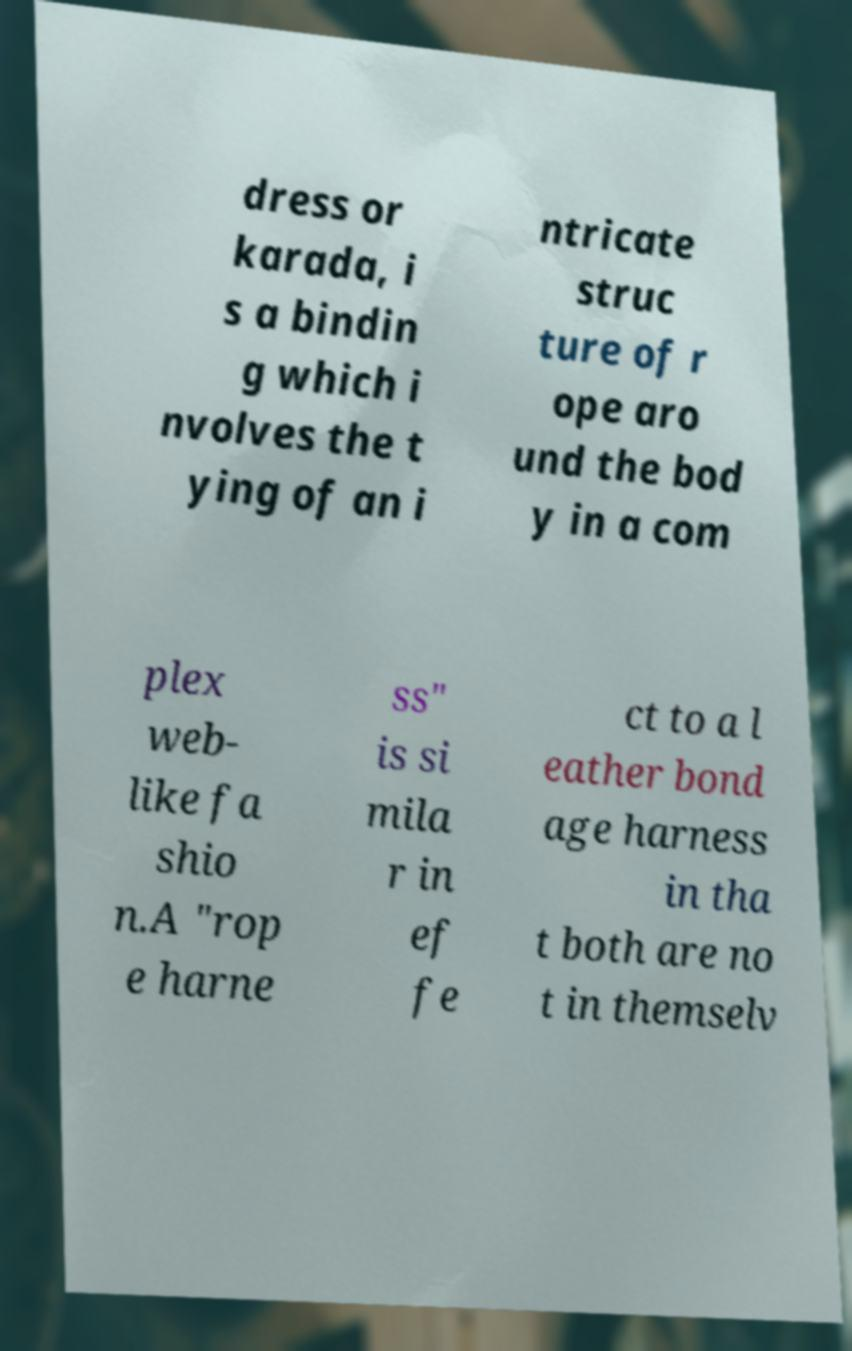There's text embedded in this image that I need extracted. Can you transcribe it verbatim? dress or karada, i s a bindin g which i nvolves the t ying of an i ntricate struc ture of r ope aro und the bod y in a com plex web- like fa shio n.A "rop e harne ss" is si mila r in ef fe ct to a l eather bond age harness in tha t both are no t in themselv 